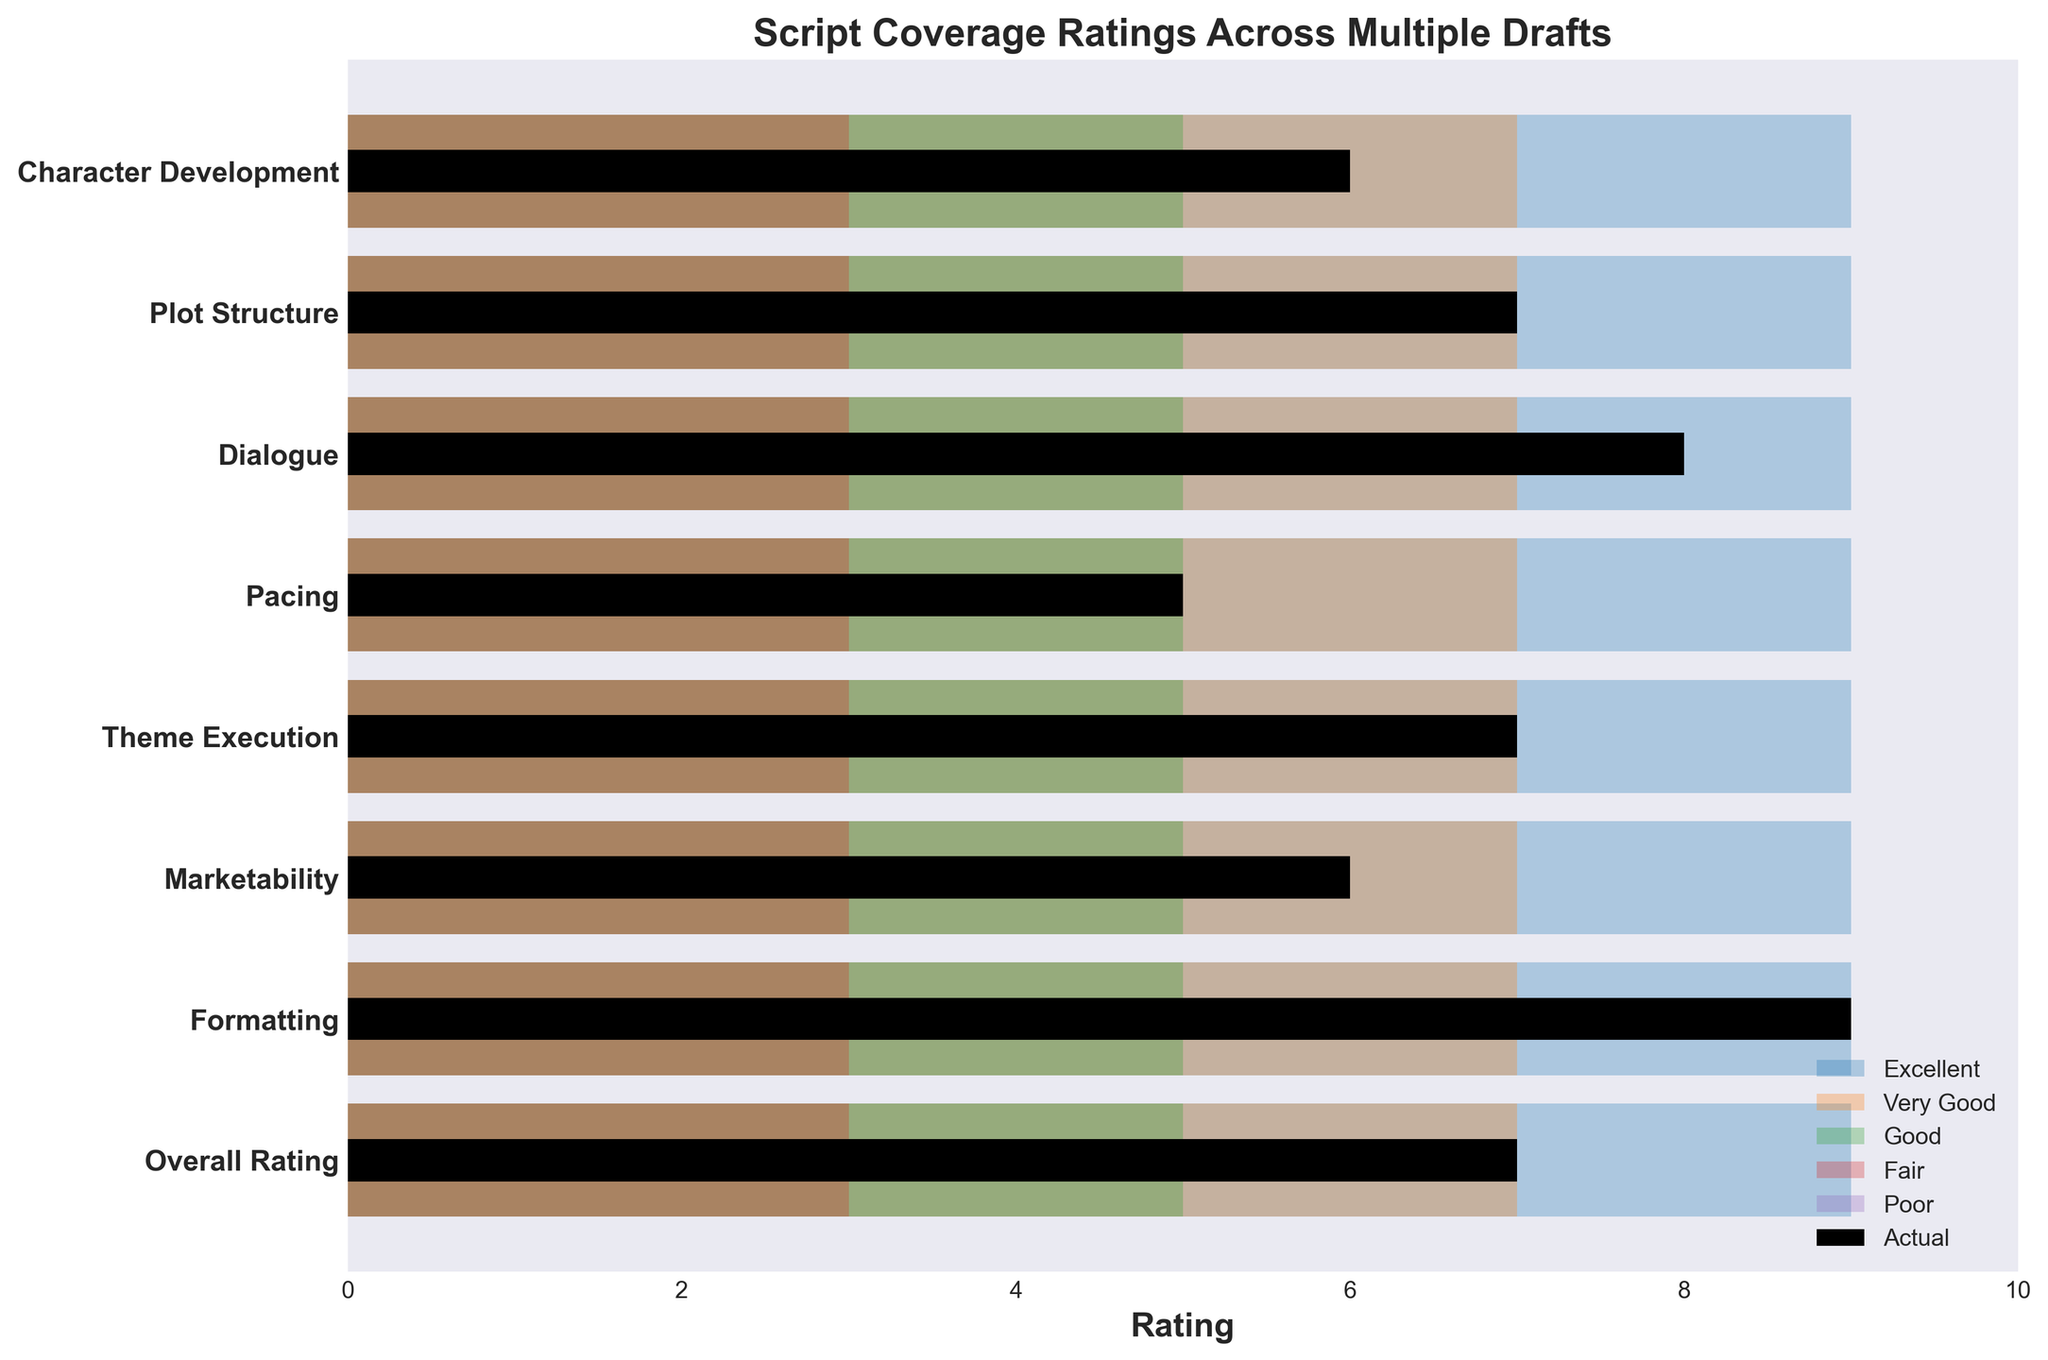What's the title of the chart? The title of the chart is typically displayed at the top of the figure. It provides a clear summary of what the data visualization represents.
Answer: Script Coverage Ratings Across Multiple Drafts Which category has the highest actual rating? To find this, look at the tallest black bar in the figure, which represents the actual ratings.
Answer: Formatting What is the actual rating for Dialogue? Identify the black bar corresponding to the Dialogue category and note its length within the rating scale.
Answer: 8 Which category has the lowest actual rating? Identify the black bar that is shortest among all categories to determine the lowest actual rating.
Answer: Pacing How many categories have an actual rating of 7? Count the number of black bars that reach the value of 7 on the rating scale.
Answer: 3 Is the actual rating for Character Development above or below the Good rating range? Compare the black bar for Character Development against the green bar representing Good ratings (rating range of 5 to 7).
Answer: Above Which category shows the most significant disparity between its Poor and Excellent rating ranges? Subtract the Poor rating from the Excellent rating for each category and compare the differences to find the largest one.
Answer: Character Development, Plot Structure, Dialogue, Pacing, Theme Execution, Marketability, Formatting, Overall Rating (all difference: 9) How do the actual ratings compare between Theme Execution and Marketability? Check the lengths of the black bars for Theme Execution and Marketability and compare them.
Answer: Both are rated 7 If the actual rating for Plot Structure is improved by one point, what will its new rating be? Add one to the current actual rating of Plot Structure.
Answer: 8 How many rating categories are there in total? Count the total number of rating bands, which includes Poor, Fair, Good, Very Good, and Excellent.
Answer: 5 